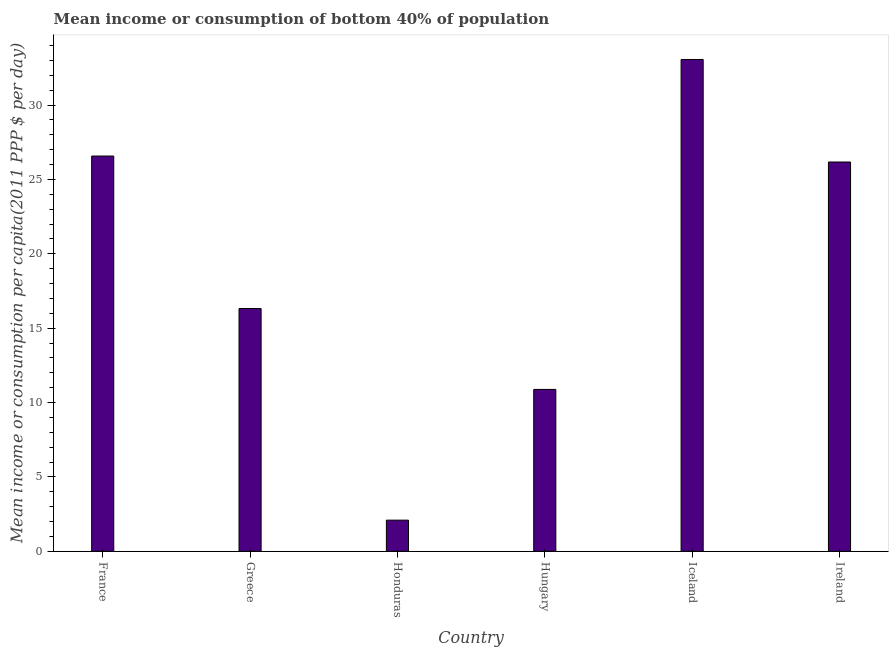What is the title of the graph?
Offer a very short reply. Mean income or consumption of bottom 40% of population. What is the label or title of the X-axis?
Offer a very short reply. Country. What is the label or title of the Y-axis?
Your answer should be very brief. Mean income or consumption per capita(2011 PPP $ per day). What is the mean income or consumption in Hungary?
Ensure brevity in your answer.  10.89. Across all countries, what is the maximum mean income or consumption?
Offer a terse response. 33.07. Across all countries, what is the minimum mean income or consumption?
Offer a very short reply. 2.1. In which country was the mean income or consumption minimum?
Keep it short and to the point. Honduras. What is the sum of the mean income or consumption?
Provide a succinct answer. 115.13. What is the difference between the mean income or consumption in Greece and Honduras?
Provide a succinct answer. 14.23. What is the average mean income or consumption per country?
Offer a very short reply. 19.19. What is the median mean income or consumption?
Provide a short and direct response. 21.25. What is the ratio of the mean income or consumption in Greece to that in Ireland?
Ensure brevity in your answer.  0.62. Is the difference between the mean income or consumption in Greece and Ireland greater than the difference between any two countries?
Make the answer very short. No. What is the difference between the highest and the second highest mean income or consumption?
Make the answer very short. 6.49. What is the difference between the highest and the lowest mean income or consumption?
Make the answer very short. 30.97. How many bars are there?
Provide a succinct answer. 6. What is the difference between two consecutive major ticks on the Y-axis?
Provide a succinct answer. 5. What is the Mean income or consumption per capita(2011 PPP $ per day) of France?
Keep it short and to the point. 26.58. What is the Mean income or consumption per capita(2011 PPP $ per day) of Greece?
Offer a terse response. 16.32. What is the Mean income or consumption per capita(2011 PPP $ per day) in Honduras?
Your response must be concise. 2.1. What is the Mean income or consumption per capita(2011 PPP $ per day) in Hungary?
Keep it short and to the point. 10.89. What is the Mean income or consumption per capita(2011 PPP $ per day) in Iceland?
Offer a terse response. 33.07. What is the Mean income or consumption per capita(2011 PPP $ per day) of Ireland?
Your answer should be compact. 26.17. What is the difference between the Mean income or consumption per capita(2011 PPP $ per day) in France and Greece?
Provide a short and direct response. 10.25. What is the difference between the Mean income or consumption per capita(2011 PPP $ per day) in France and Honduras?
Provide a succinct answer. 24.48. What is the difference between the Mean income or consumption per capita(2011 PPP $ per day) in France and Hungary?
Your answer should be compact. 15.69. What is the difference between the Mean income or consumption per capita(2011 PPP $ per day) in France and Iceland?
Keep it short and to the point. -6.49. What is the difference between the Mean income or consumption per capita(2011 PPP $ per day) in France and Ireland?
Offer a terse response. 0.4. What is the difference between the Mean income or consumption per capita(2011 PPP $ per day) in Greece and Honduras?
Provide a succinct answer. 14.23. What is the difference between the Mean income or consumption per capita(2011 PPP $ per day) in Greece and Hungary?
Provide a succinct answer. 5.44. What is the difference between the Mean income or consumption per capita(2011 PPP $ per day) in Greece and Iceland?
Ensure brevity in your answer.  -16.74. What is the difference between the Mean income or consumption per capita(2011 PPP $ per day) in Greece and Ireland?
Make the answer very short. -9.85. What is the difference between the Mean income or consumption per capita(2011 PPP $ per day) in Honduras and Hungary?
Your response must be concise. -8.79. What is the difference between the Mean income or consumption per capita(2011 PPP $ per day) in Honduras and Iceland?
Keep it short and to the point. -30.97. What is the difference between the Mean income or consumption per capita(2011 PPP $ per day) in Honduras and Ireland?
Your answer should be compact. -24.08. What is the difference between the Mean income or consumption per capita(2011 PPP $ per day) in Hungary and Iceland?
Keep it short and to the point. -22.18. What is the difference between the Mean income or consumption per capita(2011 PPP $ per day) in Hungary and Ireland?
Offer a terse response. -15.29. What is the difference between the Mean income or consumption per capita(2011 PPP $ per day) in Iceland and Ireland?
Give a very brief answer. 6.89. What is the ratio of the Mean income or consumption per capita(2011 PPP $ per day) in France to that in Greece?
Keep it short and to the point. 1.63. What is the ratio of the Mean income or consumption per capita(2011 PPP $ per day) in France to that in Honduras?
Keep it short and to the point. 12.67. What is the ratio of the Mean income or consumption per capita(2011 PPP $ per day) in France to that in Hungary?
Ensure brevity in your answer.  2.44. What is the ratio of the Mean income or consumption per capita(2011 PPP $ per day) in France to that in Iceland?
Offer a very short reply. 0.8. What is the ratio of the Mean income or consumption per capita(2011 PPP $ per day) in France to that in Ireland?
Your answer should be compact. 1.01. What is the ratio of the Mean income or consumption per capita(2011 PPP $ per day) in Greece to that in Honduras?
Your response must be concise. 7.78. What is the ratio of the Mean income or consumption per capita(2011 PPP $ per day) in Greece to that in Hungary?
Your answer should be compact. 1.5. What is the ratio of the Mean income or consumption per capita(2011 PPP $ per day) in Greece to that in Iceland?
Provide a short and direct response. 0.49. What is the ratio of the Mean income or consumption per capita(2011 PPP $ per day) in Greece to that in Ireland?
Make the answer very short. 0.62. What is the ratio of the Mean income or consumption per capita(2011 PPP $ per day) in Honduras to that in Hungary?
Make the answer very short. 0.19. What is the ratio of the Mean income or consumption per capita(2011 PPP $ per day) in Honduras to that in Iceland?
Your answer should be compact. 0.06. What is the ratio of the Mean income or consumption per capita(2011 PPP $ per day) in Honduras to that in Ireland?
Offer a terse response. 0.08. What is the ratio of the Mean income or consumption per capita(2011 PPP $ per day) in Hungary to that in Iceland?
Give a very brief answer. 0.33. What is the ratio of the Mean income or consumption per capita(2011 PPP $ per day) in Hungary to that in Ireland?
Ensure brevity in your answer.  0.42. What is the ratio of the Mean income or consumption per capita(2011 PPP $ per day) in Iceland to that in Ireland?
Offer a very short reply. 1.26. 